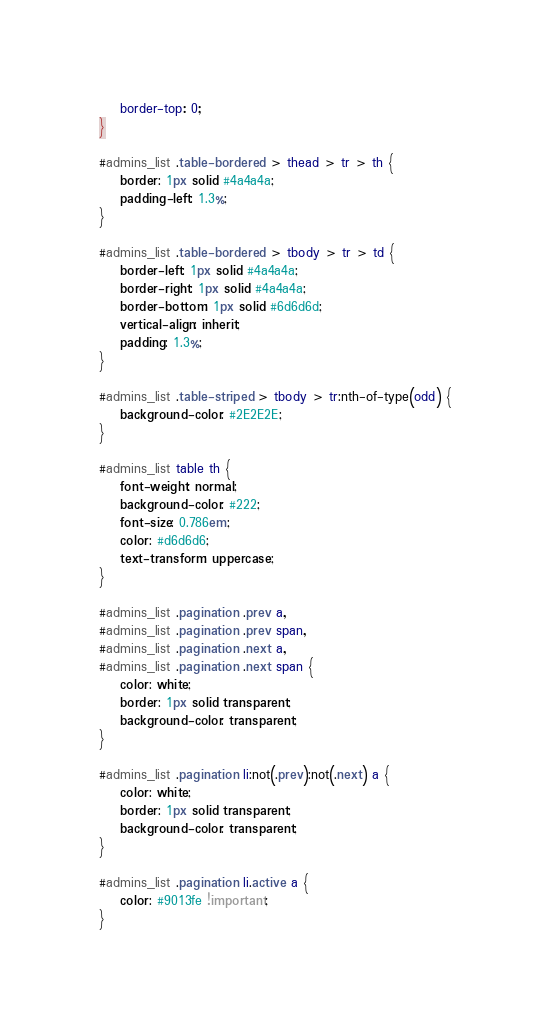<code> <loc_0><loc_0><loc_500><loc_500><_CSS_>	border-top: 0;
}

#admins_list .table-bordered > thead > tr > th {
	border: 1px solid #4a4a4a;
	padding-left: 1.3%;
}

#admins_list .table-bordered > tbody > tr > td {
	border-left: 1px solid #4a4a4a;
	border-right: 1px solid #4a4a4a;
	border-bottom: 1px solid #6d6d6d;
	vertical-align: inherit;
	padding: 1.3%;
}

#admins_list .table-striped > tbody > tr:nth-of-type(odd) {
	background-color: #2E2E2E;
}

#admins_list table th {
	font-weight: normal;
	background-color: #222;
	font-size: 0.786em;
	color: #d6d6d6;
	text-transform: uppercase;
}

#admins_list .pagination .prev a,
#admins_list .pagination .prev span,
#admins_list .pagination .next a,
#admins_list .pagination .next span {
	color: white;
	border: 1px solid transparent;
	background-color: transparent;
}

#admins_list .pagination li:not(.prev):not(.next) a {
	color: white;
	border: 1px solid transparent;
	background-color: transparent;
}

#admins_list .pagination li.active a {
	color: #9013fe !important;
}
</code> 